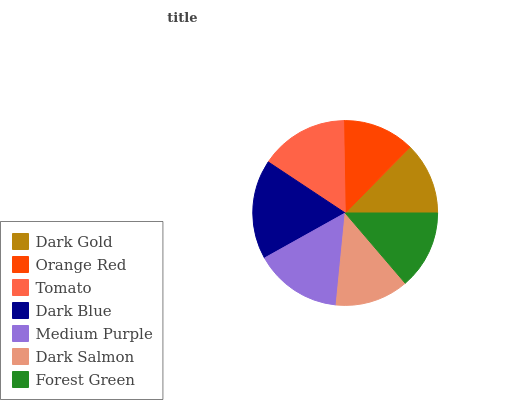Is Dark Gold the minimum?
Answer yes or no. Yes. Is Dark Blue the maximum?
Answer yes or no. Yes. Is Orange Red the minimum?
Answer yes or no. No. Is Orange Red the maximum?
Answer yes or no. No. Is Orange Red greater than Dark Gold?
Answer yes or no. Yes. Is Dark Gold less than Orange Red?
Answer yes or no. Yes. Is Dark Gold greater than Orange Red?
Answer yes or no. No. Is Orange Red less than Dark Gold?
Answer yes or no. No. Is Forest Green the high median?
Answer yes or no. Yes. Is Forest Green the low median?
Answer yes or no. Yes. Is Dark Blue the high median?
Answer yes or no. No. Is Dark Salmon the low median?
Answer yes or no. No. 